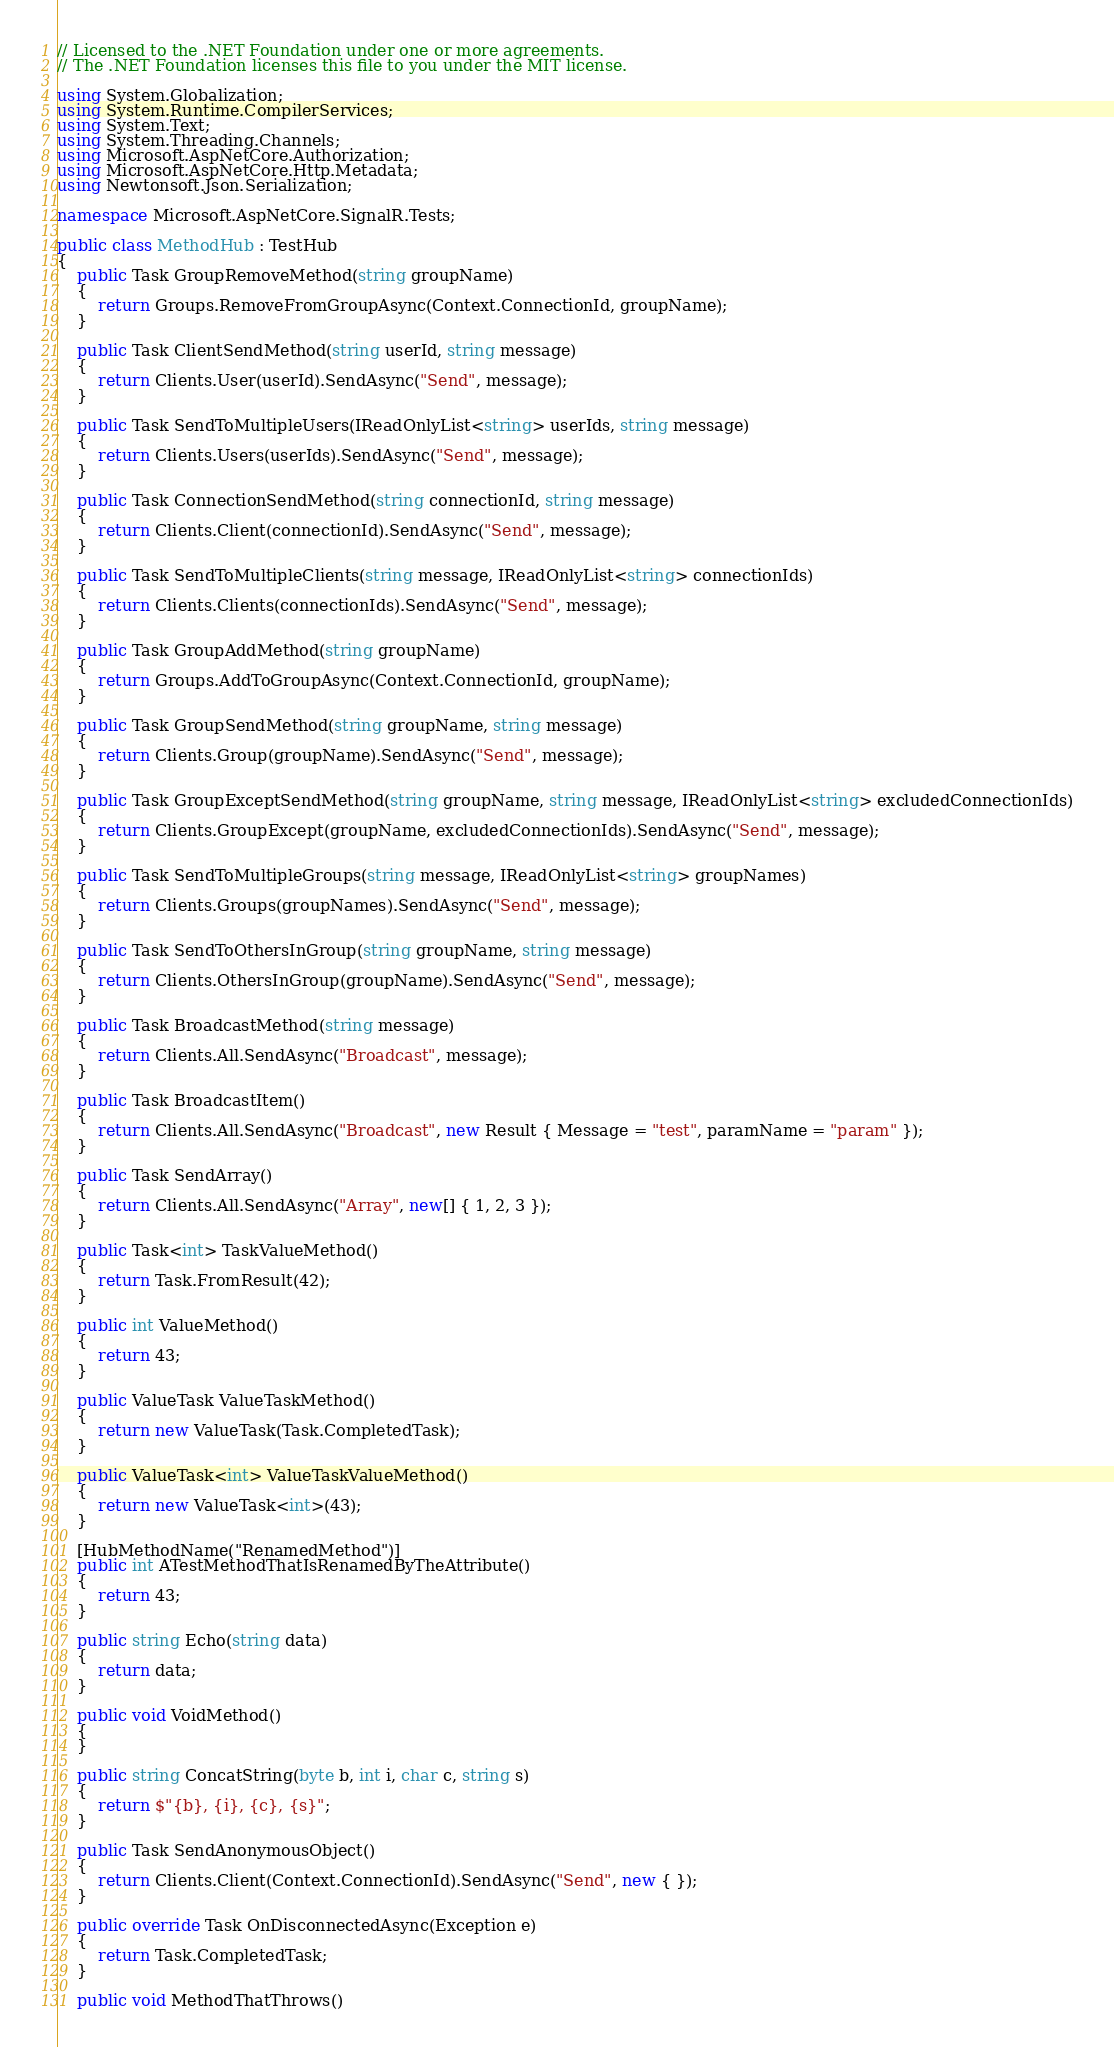<code> <loc_0><loc_0><loc_500><loc_500><_C#_>// Licensed to the .NET Foundation under one or more agreements.
// The .NET Foundation licenses this file to you under the MIT license.

using System.Globalization;
using System.Runtime.CompilerServices;
using System.Text;
using System.Threading.Channels;
using Microsoft.AspNetCore.Authorization;
using Microsoft.AspNetCore.Http.Metadata;
using Newtonsoft.Json.Serialization;

namespace Microsoft.AspNetCore.SignalR.Tests;

public class MethodHub : TestHub
{
    public Task GroupRemoveMethod(string groupName)
    {
        return Groups.RemoveFromGroupAsync(Context.ConnectionId, groupName);
    }

    public Task ClientSendMethod(string userId, string message)
    {
        return Clients.User(userId).SendAsync("Send", message);
    }

    public Task SendToMultipleUsers(IReadOnlyList<string> userIds, string message)
    {
        return Clients.Users(userIds).SendAsync("Send", message);
    }

    public Task ConnectionSendMethod(string connectionId, string message)
    {
        return Clients.Client(connectionId).SendAsync("Send", message);
    }

    public Task SendToMultipleClients(string message, IReadOnlyList<string> connectionIds)
    {
        return Clients.Clients(connectionIds).SendAsync("Send", message);
    }

    public Task GroupAddMethod(string groupName)
    {
        return Groups.AddToGroupAsync(Context.ConnectionId, groupName);
    }

    public Task GroupSendMethod(string groupName, string message)
    {
        return Clients.Group(groupName).SendAsync("Send", message);
    }

    public Task GroupExceptSendMethod(string groupName, string message, IReadOnlyList<string> excludedConnectionIds)
    {
        return Clients.GroupExcept(groupName, excludedConnectionIds).SendAsync("Send", message);
    }

    public Task SendToMultipleGroups(string message, IReadOnlyList<string> groupNames)
    {
        return Clients.Groups(groupNames).SendAsync("Send", message);
    }

    public Task SendToOthersInGroup(string groupName, string message)
    {
        return Clients.OthersInGroup(groupName).SendAsync("Send", message);
    }

    public Task BroadcastMethod(string message)
    {
        return Clients.All.SendAsync("Broadcast", message);
    }

    public Task BroadcastItem()
    {
        return Clients.All.SendAsync("Broadcast", new Result { Message = "test", paramName = "param" });
    }

    public Task SendArray()
    {
        return Clients.All.SendAsync("Array", new[] { 1, 2, 3 });
    }

    public Task<int> TaskValueMethod()
    {
        return Task.FromResult(42);
    }

    public int ValueMethod()
    {
        return 43;
    }

    public ValueTask ValueTaskMethod()
    {
        return new ValueTask(Task.CompletedTask);
    }

    public ValueTask<int> ValueTaskValueMethod()
    {
        return new ValueTask<int>(43);
    }

    [HubMethodName("RenamedMethod")]
    public int ATestMethodThatIsRenamedByTheAttribute()
    {
        return 43;
    }

    public string Echo(string data)
    {
        return data;
    }

    public void VoidMethod()
    {
    }

    public string ConcatString(byte b, int i, char c, string s)
    {
        return $"{b}, {i}, {c}, {s}";
    }

    public Task SendAnonymousObject()
    {
        return Clients.Client(Context.ConnectionId).SendAsync("Send", new { });
    }

    public override Task OnDisconnectedAsync(Exception e)
    {
        return Task.CompletedTask;
    }

    public void MethodThatThrows()</code> 